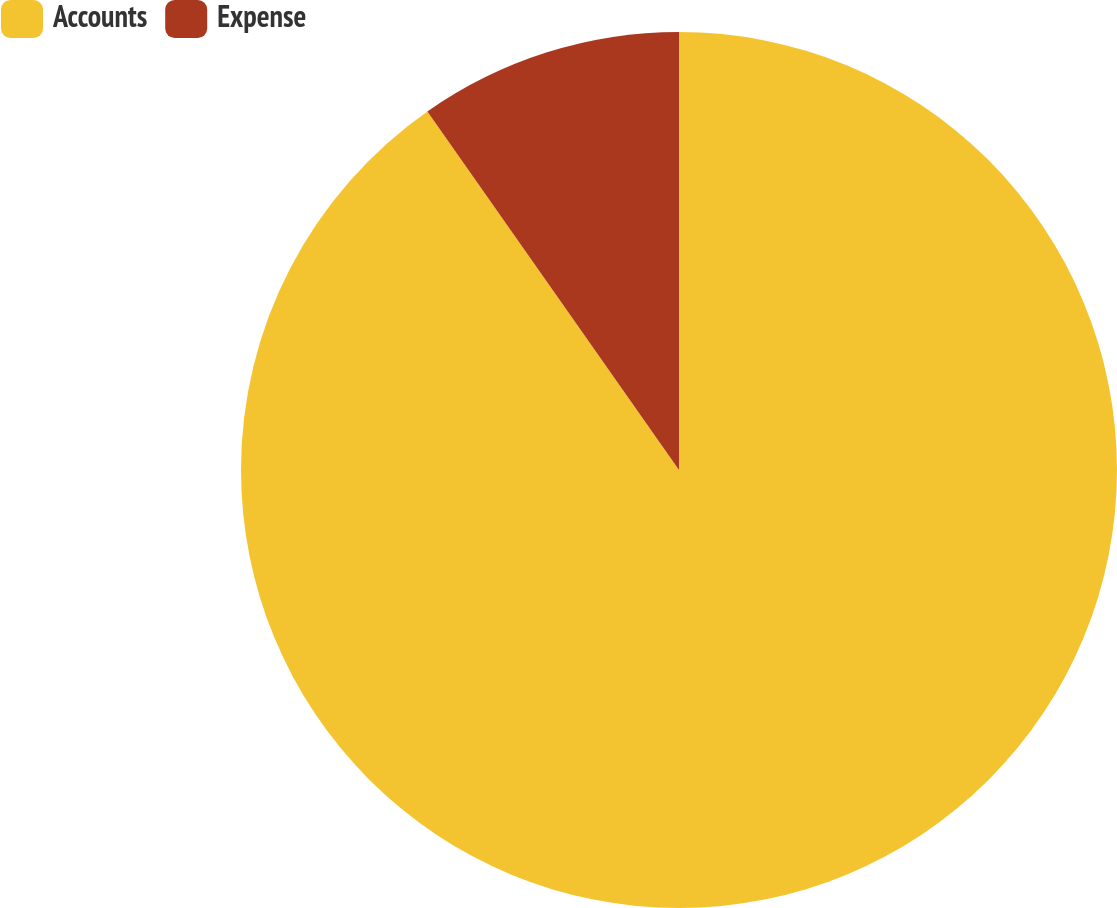<chart> <loc_0><loc_0><loc_500><loc_500><pie_chart><fcel>Accounts<fcel>Expense<nl><fcel>90.26%<fcel>9.74%<nl></chart> 